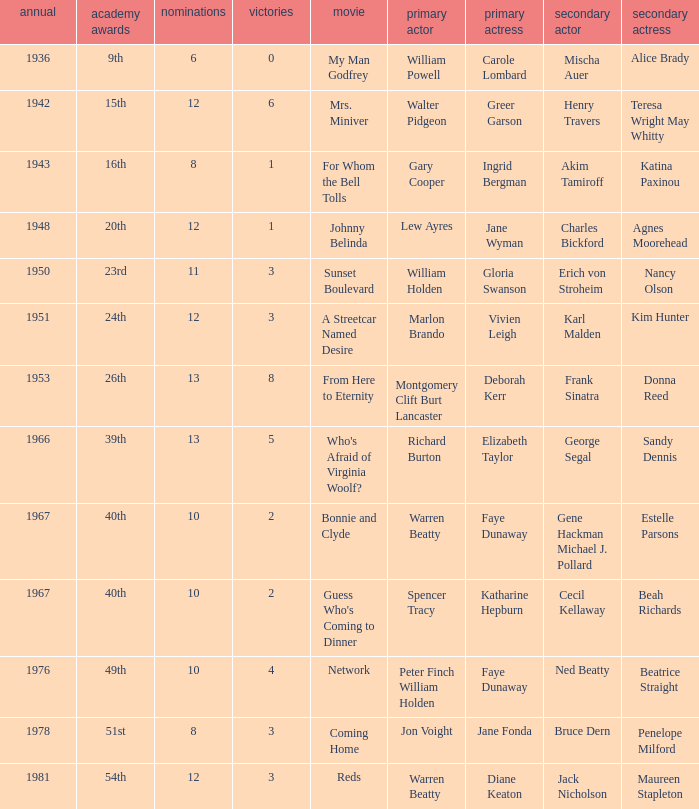Which film had Charles Bickford as supporting actor? Johnny Belinda. 